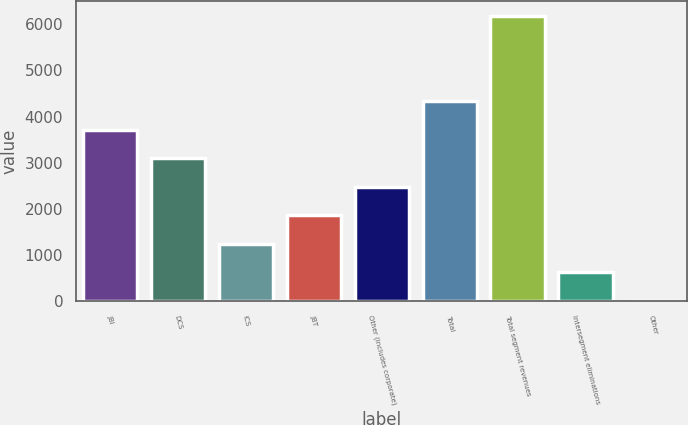Convert chart. <chart><loc_0><loc_0><loc_500><loc_500><bar_chart><fcel>JBI<fcel>DCS<fcel>ICS<fcel>JBT<fcel>Other (includes corporate)<fcel>Total<fcel>Total segment revenues<fcel>Intersegment eliminations<fcel>Other<nl><fcel>3717<fcel>3100<fcel>1249<fcel>1866<fcel>2483<fcel>4334<fcel>6185<fcel>632<fcel>15<nl></chart> 